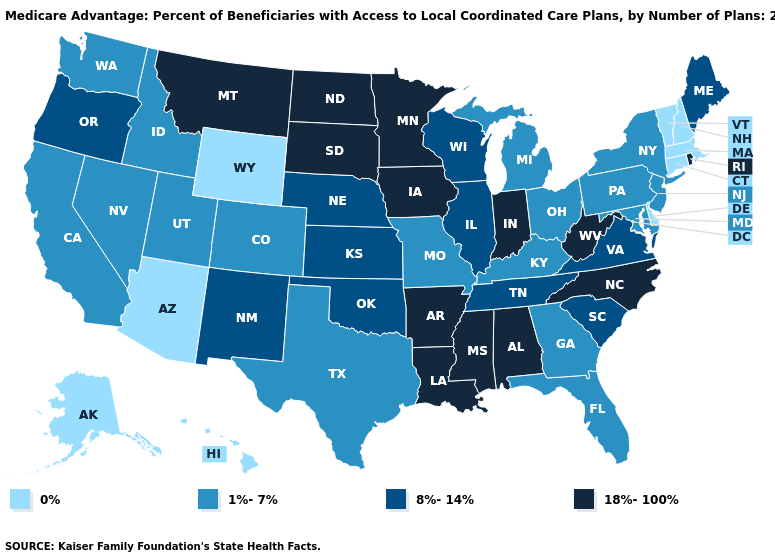Among the states that border Nevada , does Arizona have the lowest value?
Short answer required. Yes. What is the lowest value in states that border Kentucky?
Give a very brief answer. 1%-7%. What is the value of New Hampshire?
Keep it brief. 0%. What is the lowest value in the USA?
Quick response, please. 0%. What is the value of Virginia?
Quick response, please. 8%-14%. Among the states that border Massachusetts , does New Hampshire have the lowest value?
Answer briefly. Yes. Does Virginia have the highest value in the USA?
Keep it brief. No. Does the first symbol in the legend represent the smallest category?
Write a very short answer. Yes. Name the states that have a value in the range 1%-7%?
Give a very brief answer. California, Colorado, Florida, Georgia, Idaho, Kentucky, Maryland, Michigan, Missouri, New Jersey, Nevada, New York, Ohio, Pennsylvania, Texas, Utah, Washington. What is the lowest value in the MidWest?
Write a very short answer. 1%-7%. Among the states that border Illinois , which have the highest value?
Concise answer only. Iowa, Indiana. What is the value of New Jersey?
Concise answer only. 1%-7%. Name the states that have a value in the range 8%-14%?
Be succinct. Illinois, Kansas, Maine, Nebraska, New Mexico, Oklahoma, Oregon, South Carolina, Tennessee, Virginia, Wisconsin. Does the map have missing data?
Quick response, please. No. Does Oregon have the highest value in the West?
Keep it brief. No. 